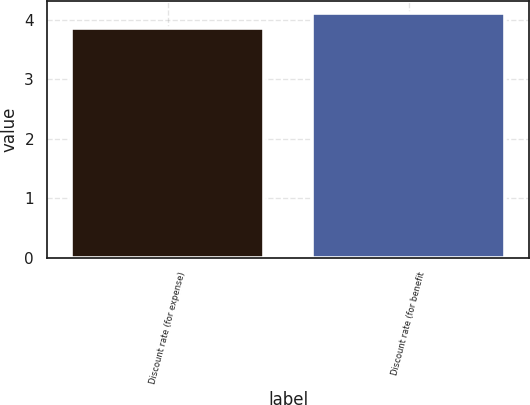Convert chart. <chart><loc_0><loc_0><loc_500><loc_500><bar_chart><fcel>Discount rate (for expense)<fcel>Discount rate (for benefit<nl><fcel>3.87<fcel>4.12<nl></chart> 